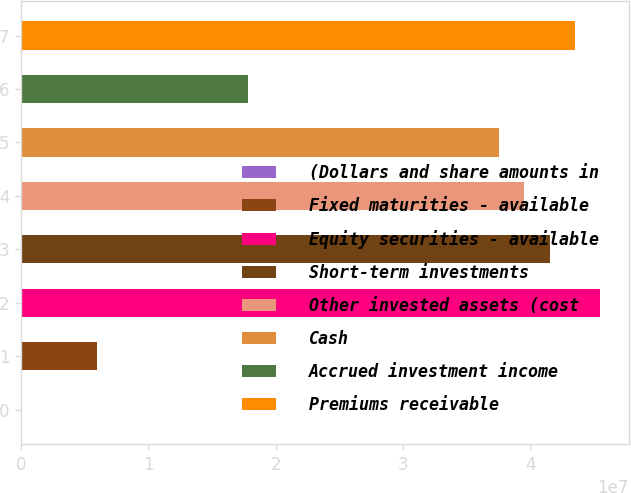<chart> <loc_0><loc_0><loc_500><loc_500><bar_chart><fcel>(Dollars and share amounts in<fcel>Fixed maturities - available<fcel>Equity securities - available<fcel>Short-term investments<fcel>Other invested assets (cost<fcel>Cash<fcel>Accrued investment income<fcel>Premiums receivable<nl><fcel>2012<fcel>5.93478e+06<fcel>4.54866e+07<fcel>4.15314e+07<fcel>3.95538e+07<fcel>3.75762e+07<fcel>1.78003e+07<fcel>4.3509e+07<nl></chart> 